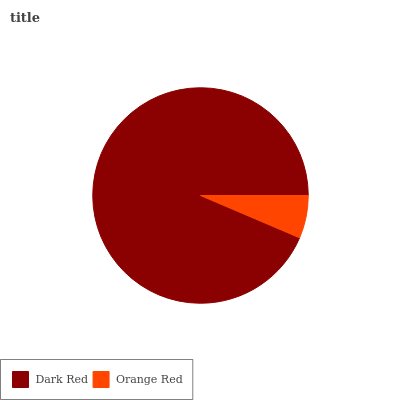Is Orange Red the minimum?
Answer yes or no. Yes. Is Dark Red the maximum?
Answer yes or no. Yes. Is Orange Red the maximum?
Answer yes or no. No. Is Dark Red greater than Orange Red?
Answer yes or no. Yes. Is Orange Red less than Dark Red?
Answer yes or no. Yes. Is Orange Red greater than Dark Red?
Answer yes or no. No. Is Dark Red less than Orange Red?
Answer yes or no. No. Is Dark Red the high median?
Answer yes or no. Yes. Is Orange Red the low median?
Answer yes or no. Yes. Is Orange Red the high median?
Answer yes or no. No. Is Dark Red the low median?
Answer yes or no. No. 